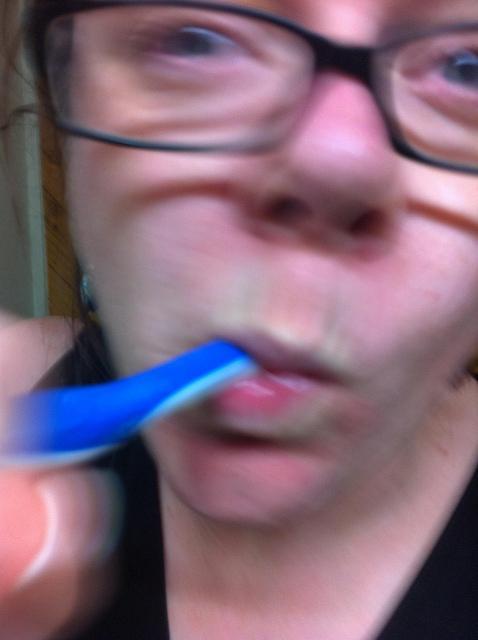How many toothbrushes are pictured?
Give a very brief answer. 1. How many sets of three carrots are on the plate?
Give a very brief answer. 0. 